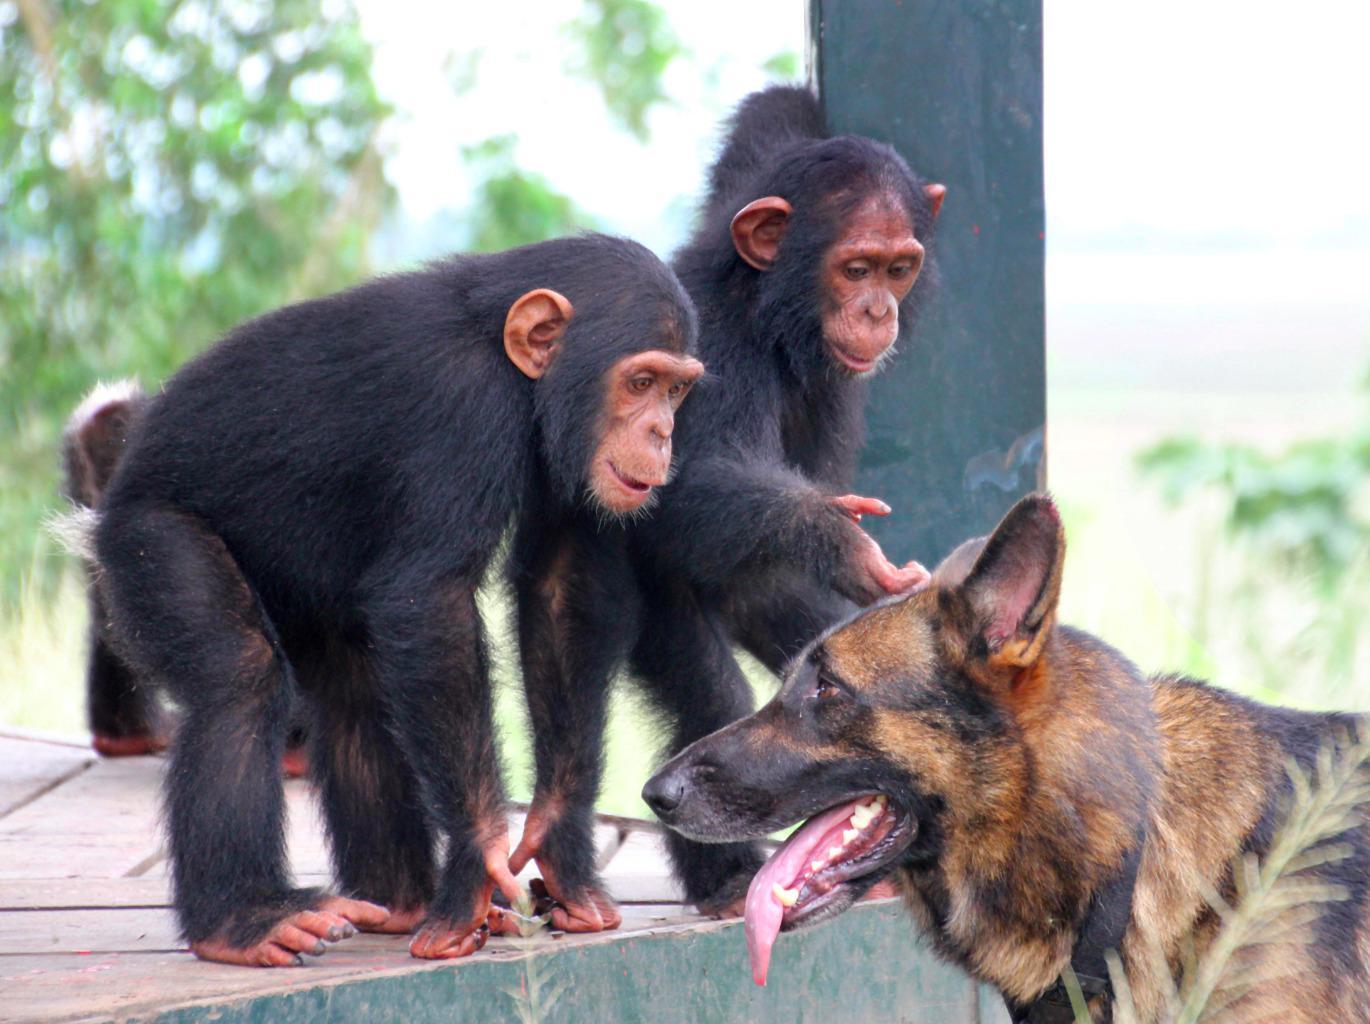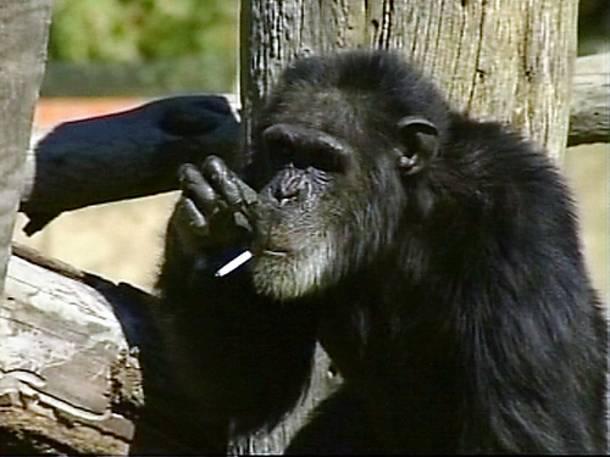The first image is the image on the left, the second image is the image on the right. Examine the images to the left and right. Is the description "One image includes two apes sitting directly face to face, while the other image features chimps sitting one behind the other." accurate? Answer yes or no. No. The first image is the image on the left, the second image is the image on the right. For the images shown, is this caption "There is exactly three chimpanzees in the right image." true? Answer yes or no. No. 